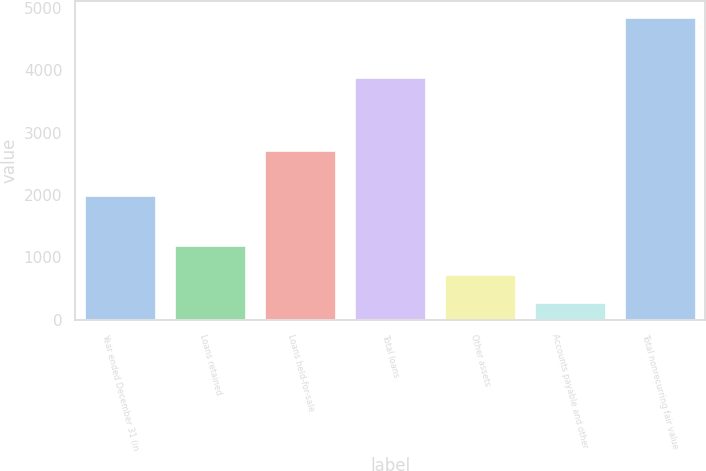<chart> <loc_0><loc_0><loc_500><loc_500><bar_chart><fcel>Year ended December 31 (in<fcel>Loans retained<fcel>Loans held-for-sale<fcel>Total loans<fcel>Other assets<fcel>Accounts payable and other<fcel>Total nonrecurring fair value<nl><fcel>2008<fcel>1199.4<fcel>2728<fcel>3887<fcel>742.2<fcel>285<fcel>4857<nl></chart> 